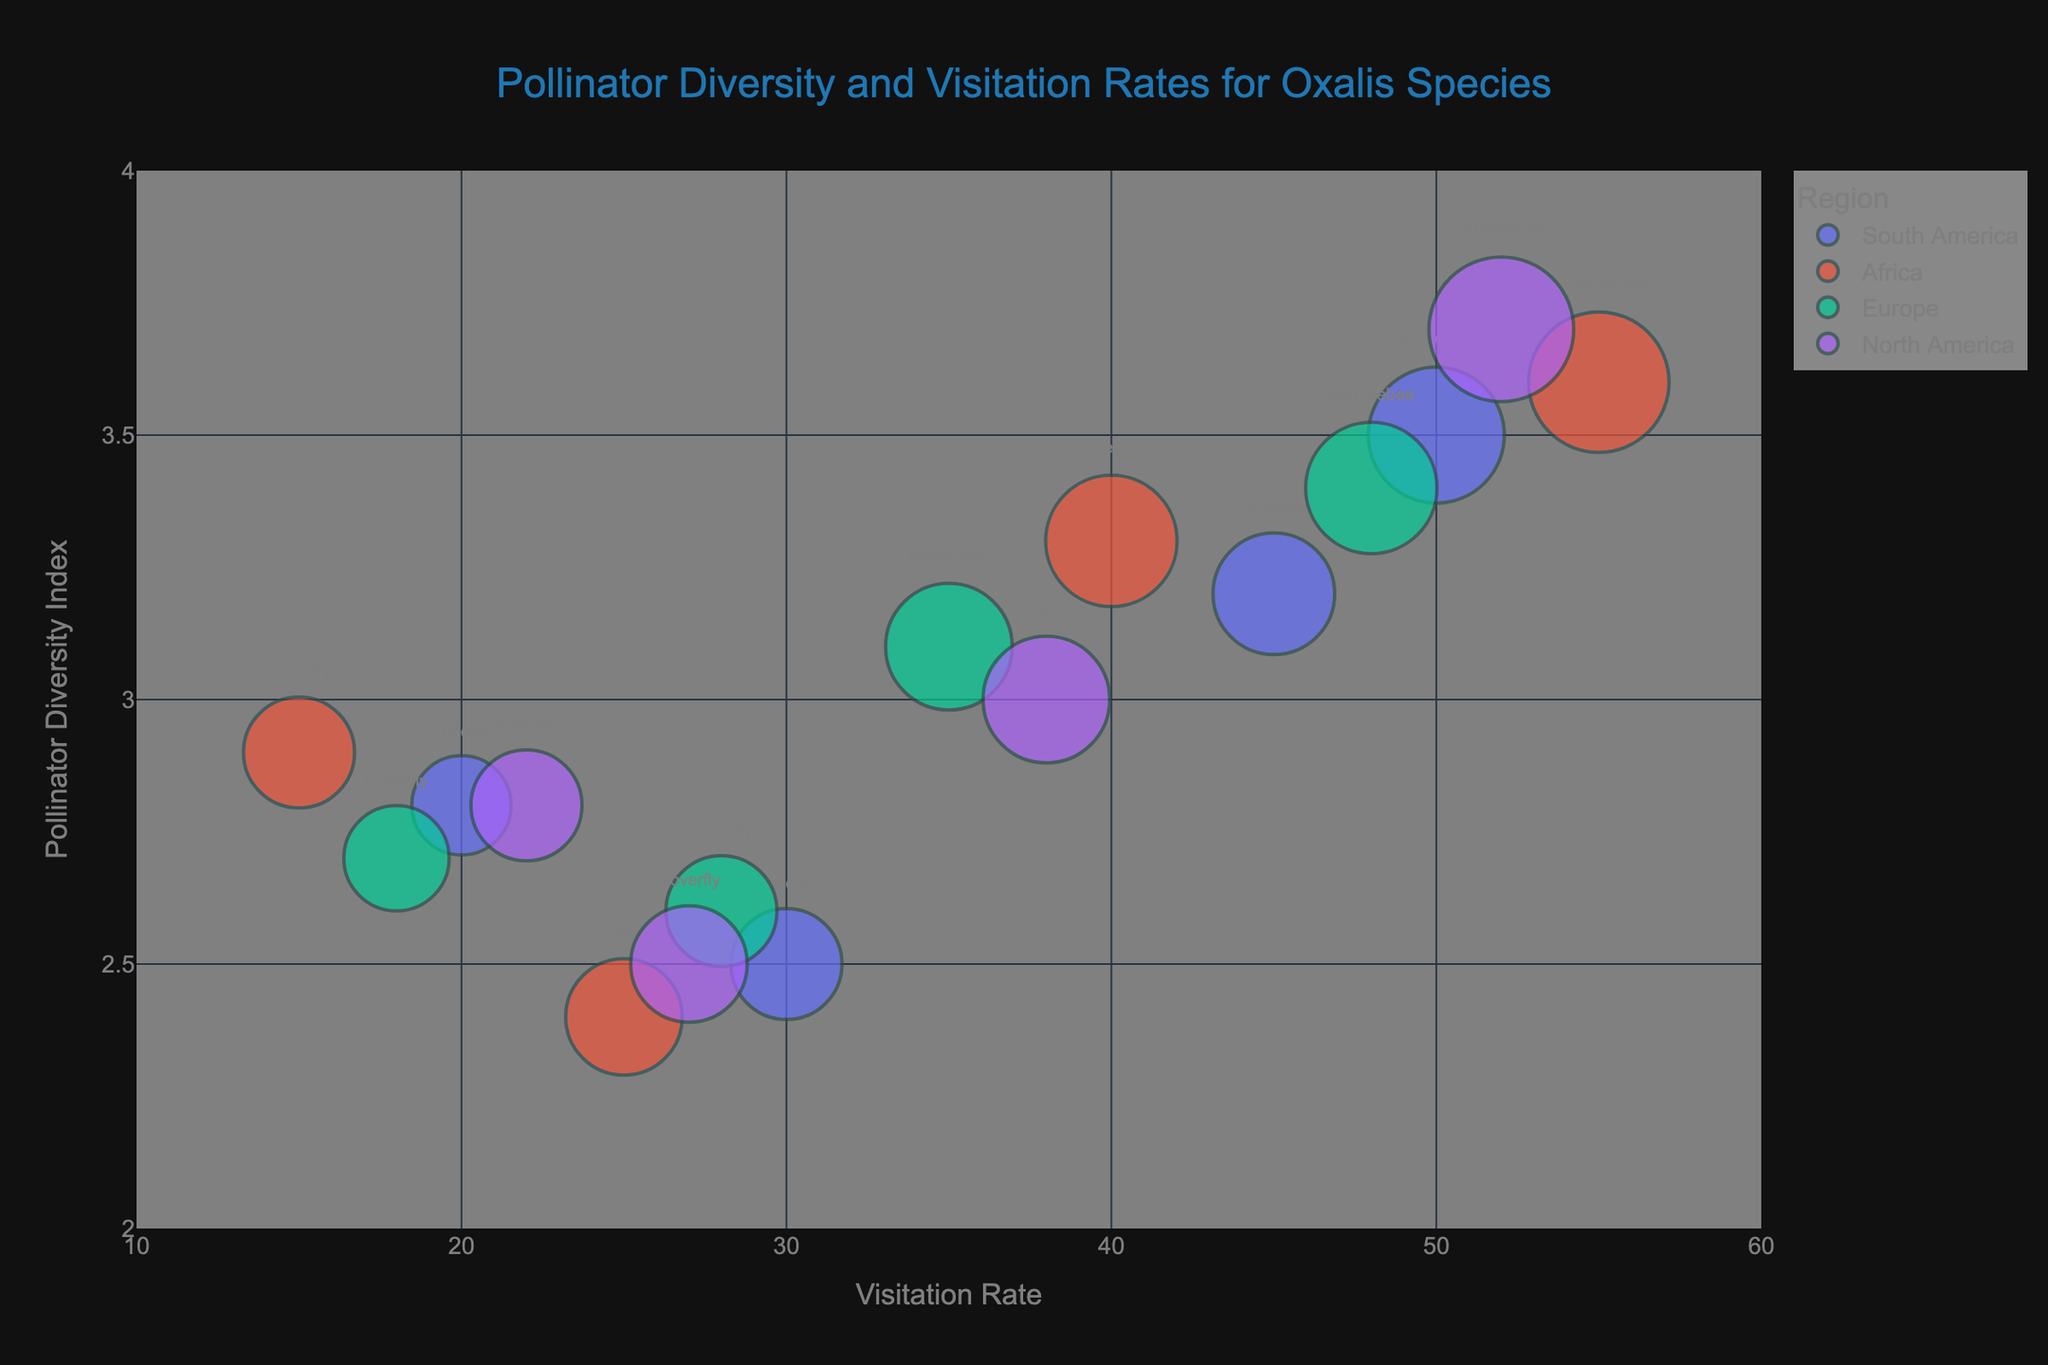What is the title of the bubble chart? The title is located at the top of the bubble chart and it describes the main topic of the visualization.
Answer: Pollinator Diversity and Visitation Rates for Oxalis Species Which region has the highest visitation rate? Look at the x-axis which represents the visitation rate and find the bubble farthest to the right. Only one region has the highest value at 55.
Answer: Africa How many Oxalis species are studied in South America? Identify the bubbles colored for South America (unique color) and count them.
Answer: Four What is the average visitation rate for Oxalis species in Europe? Find the visitation rates for all Oxalis species in Europe (35, 28, 18, 48). Sum these values and then divide by the number of species. (35 + 28 + 18 + 48) / 4 = 129 / 4 = 32.25
Answer: 32.25 Which Oxalis species has the maximum pollinator diversity index in North America? Look at the y-axis, which shows the diversity index, and find the highest point for North America. The bubble with the highest point gives the species.
Answer: Oxalis oregana Compare the visitation rates between Oxalis pes-caprae and Oxalis obtusa. Which is higher? Identify the visitation rate on the x-axis for both species and compare the values, 45 for Oxalis pes-caprae and 55 for Oxalis obtusa.
Answer: Oxalis obtusa Is the pollinator diversity index of Oxalis triangularis higher than that of Oxalis fontana? Oxalis triangularis has a diversity index of 3.5, while Oxalis fontana has 3.4. Compare these values.
Answer: Yes Which insect pollinator has the highest average flower size associated with it overall? Identify the bubbles for each pollinator and note the 'size' (Average Flower Size). Compare sizes to determine the largest. Bumblebee has the highest size at 1.7.
Answer: Bumblebee How many species in the Africa region have a visitation rate greater than 30? Identify all species in Africa and count those with a visitation rate greater than 30.
Answer: Three What's the range of visitation rates for the Hoverfly pollinator? Identify all bubbles for Hoverfly and note their visitation rates (30, 25, 28, 27). Determine the minimum and maximum values. Range = 30 - 25.
Answer: 5 